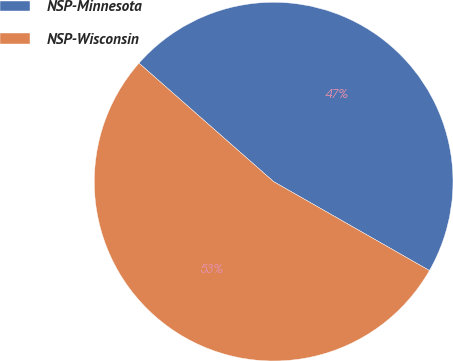Convert chart. <chart><loc_0><loc_0><loc_500><loc_500><pie_chart><fcel>NSP-Minnesota<fcel>NSP-Wisconsin<nl><fcel>46.77%<fcel>53.23%<nl></chart> 